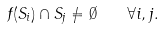<formula> <loc_0><loc_0><loc_500><loc_500>f ( S _ { i } ) \cap S _ { j } \neq \emptyset \quad \forall i , j .</formula> 